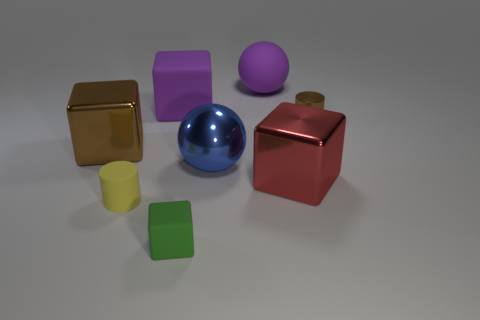Add 1 large blue shiny things. How many objects exist? 9 Subtract all spheres. How many objects are left? 6 Subtract 1 brown blocks. How many objects are left? 7 Subtract all tiny gray matte cylinders. Subtract all tiny rubber cubes. How many objects are left? 7 Add 4 green blocks. How many green blocks are left? 5 Add 1 large red blocks. How many large red blocks exist? 2 